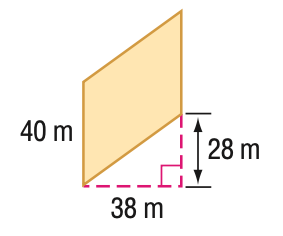Question: Find the area of the parallelogram. Round to the nearest tenth if necessary.
Choices:
A. 1064
B. 1120
C. 1520
D. 1888.1
Answer with the letter. Answer: C Question: Find the perimeter of the parallelogram. Round to the nearest tenth if necessary.
Choices:
A. 132
B. 147.5
C. 156
D. 174.4
Answer with the letter. Answer: D 